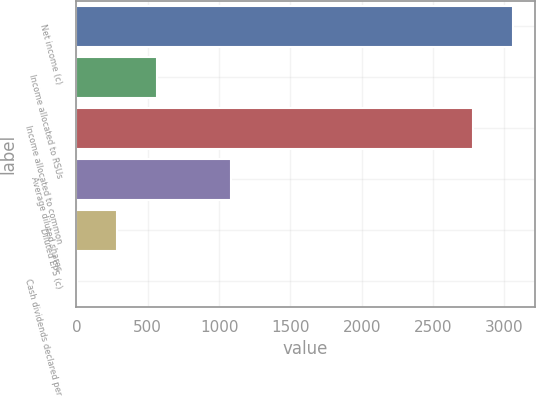Convert chart. <chart><loc_0><loc_0><loc_500><loc_500><bar_chart><fcel>Net income (c)<fcel>Income allocated to RSUs<fcel>Income allocated to common<fcel>Average diluted shares<fcel>Diluted EPS (c)<fcel>Cash dividends declared per<nl><fcel>3059.98<fcel>565.2<fcel>2778<fcel>1080<fcel>283.22<fcel>1.24<nl></chart> 